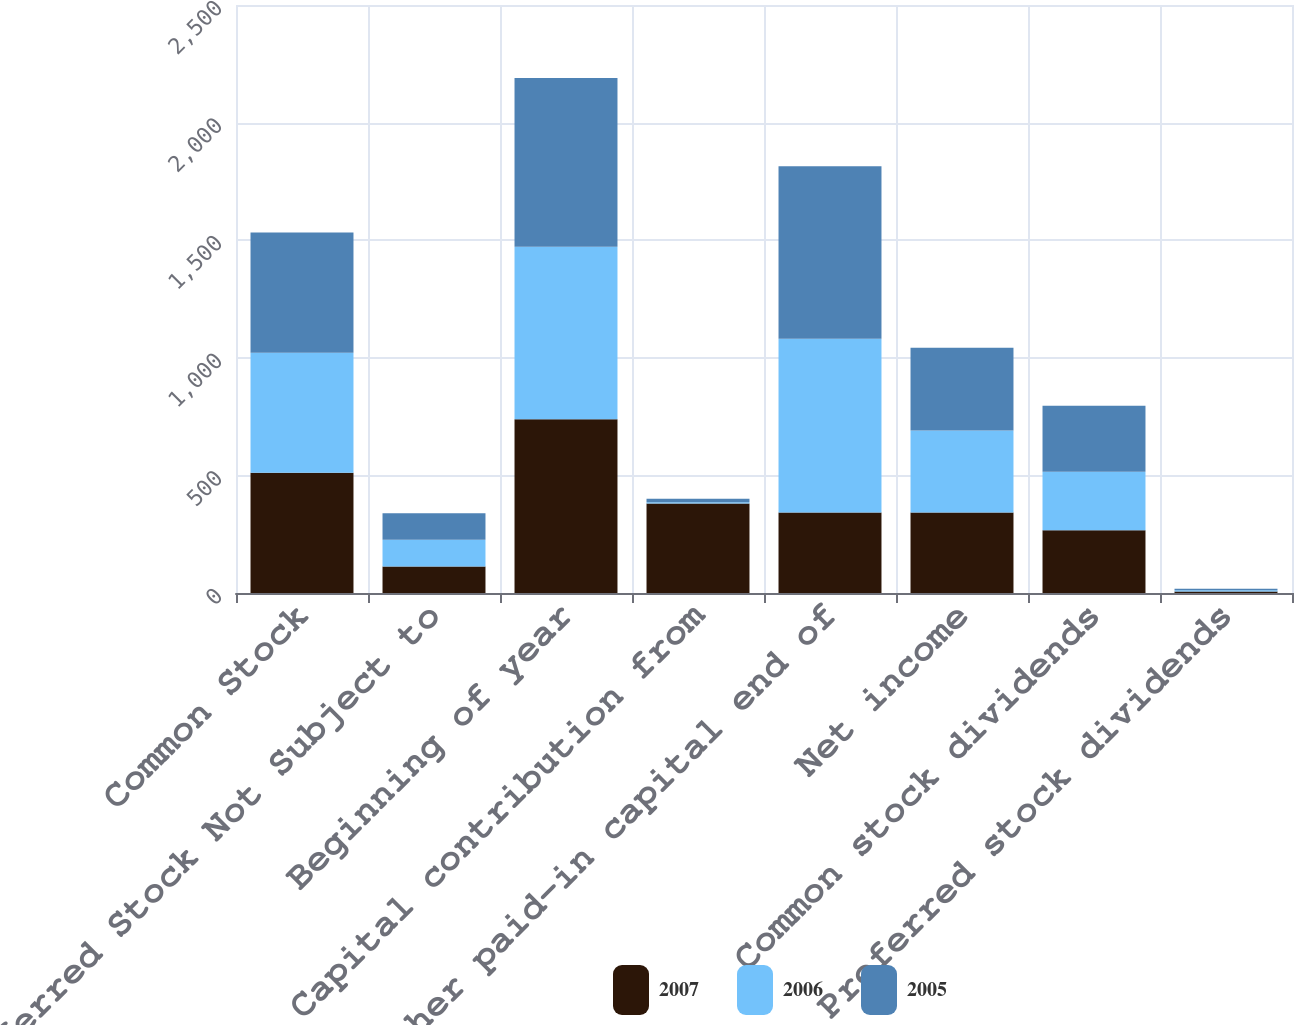<chart> <loc_0><loc_0><loc_500><loc_500><stacked_bar_chart><ecel><fcel>Common Stock<fcel>Preferred Stock Not Subject to<fcel>Beginning of year<fcel>Capital contribution from<fcel>Other paid-in capital end of<fcel>Net income<fcel>Common stock dividends<fcel>Preferred stock dividends<nl><fcel>2007<fcel>511<fcel>113<fcel>739<fcel>380<fcel>342<fcel>342<fcel>267<fcel>6<nl><fcel>2006<fcel>511<fcel>113<fcel>733<fcel>6<fcel>739<fcel>349<fcel>249<fcel>6<nl><fcel>2005<fcel>511<fcel>113<fcel>718<fcel>15<fcel>733<fcel>352<fcel>280<fcel>6<nl></chart> 